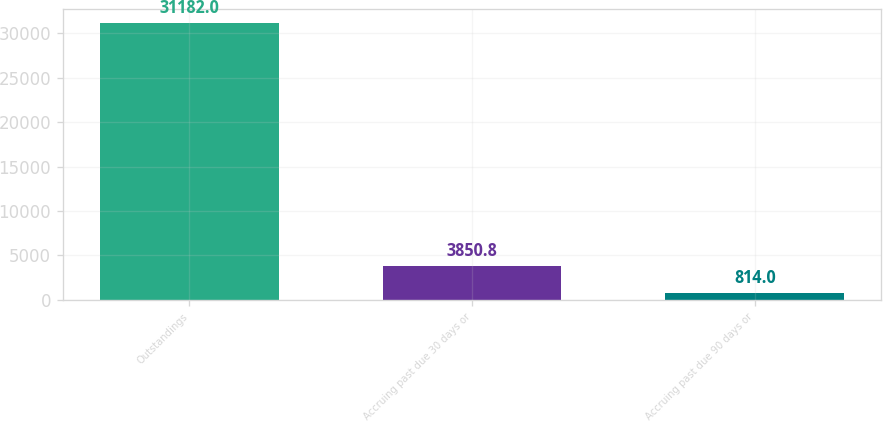Convert chart. <chart><loc_0><loc_0><loc_500><loc_500><bar_chart><fcel>Outstandings<fcel>Accruing past due 30 days or<fcel>Accruing past due 90 days or<nl><fcel>31182<fcel>3850.8<fcel>814<nl></chart> 